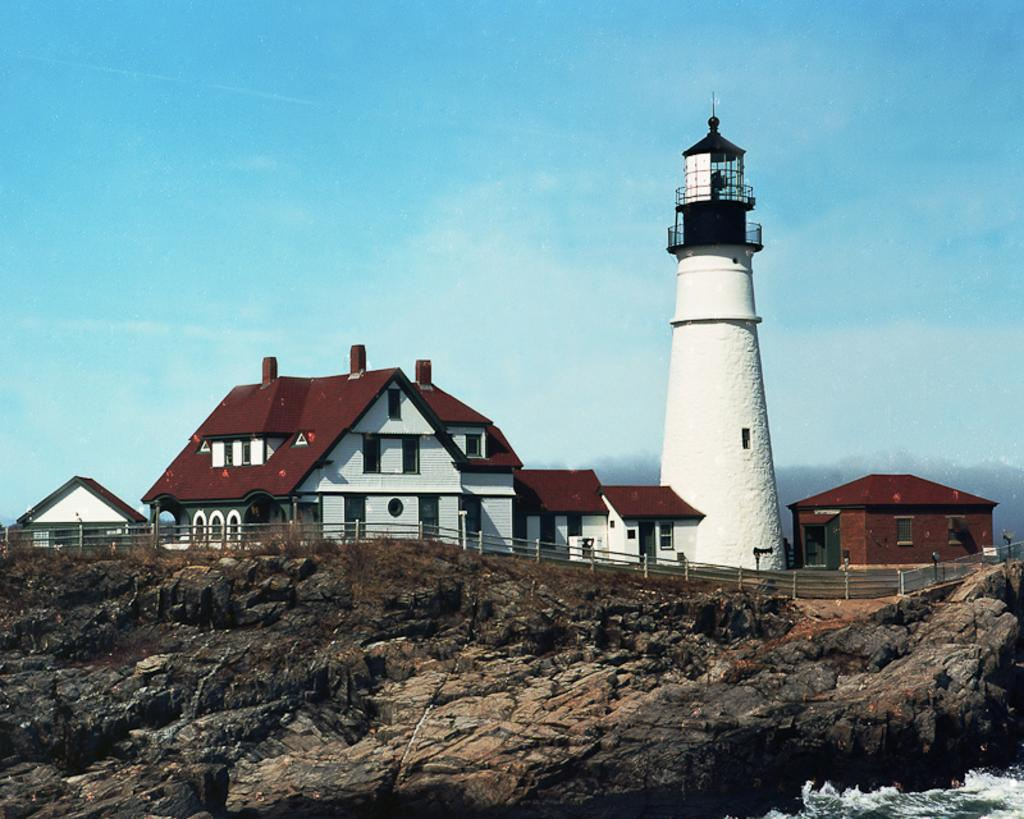What type of structures can be seen in the image? There are houses and a lighthouse in the image. What features do the houses have? The houses have windows. What type of barrier is present in the image? There is fencing in the image. What natural element can be seen in the image? There is a rock in the image. What type of vegetation is present in the image? Dry grass is present in the image. What body of water is visible in the image? There is water visible in the image. What is the color of the sky in the image? The sky is blue and white in color. What type of celery can be seen growing near the houses in the image? There is no celery present in the image. How many ants are crawling on the lighthouse in the image? There are no ants present in the image. 